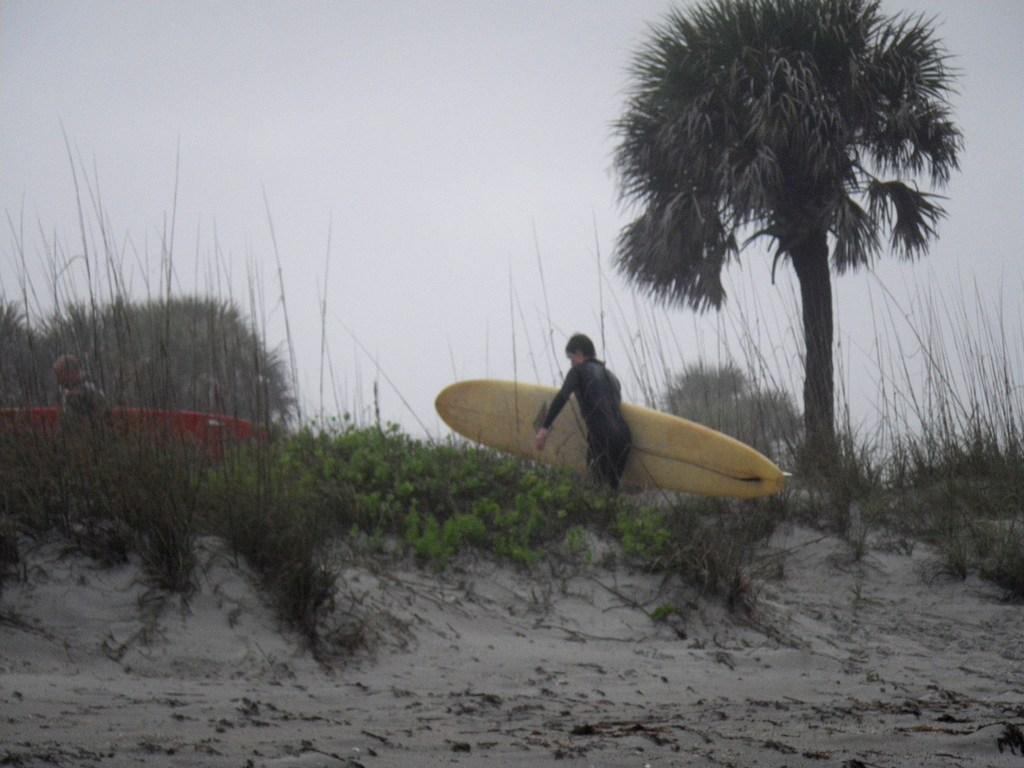Please provide a concise description of this image. In this image we can see a person holding a water skiing device in his hand. Here we can see trees and a sky. 